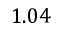<formula> <loc_0><loc_0><loc_500><loc_500>1 . 0 4</formula> 